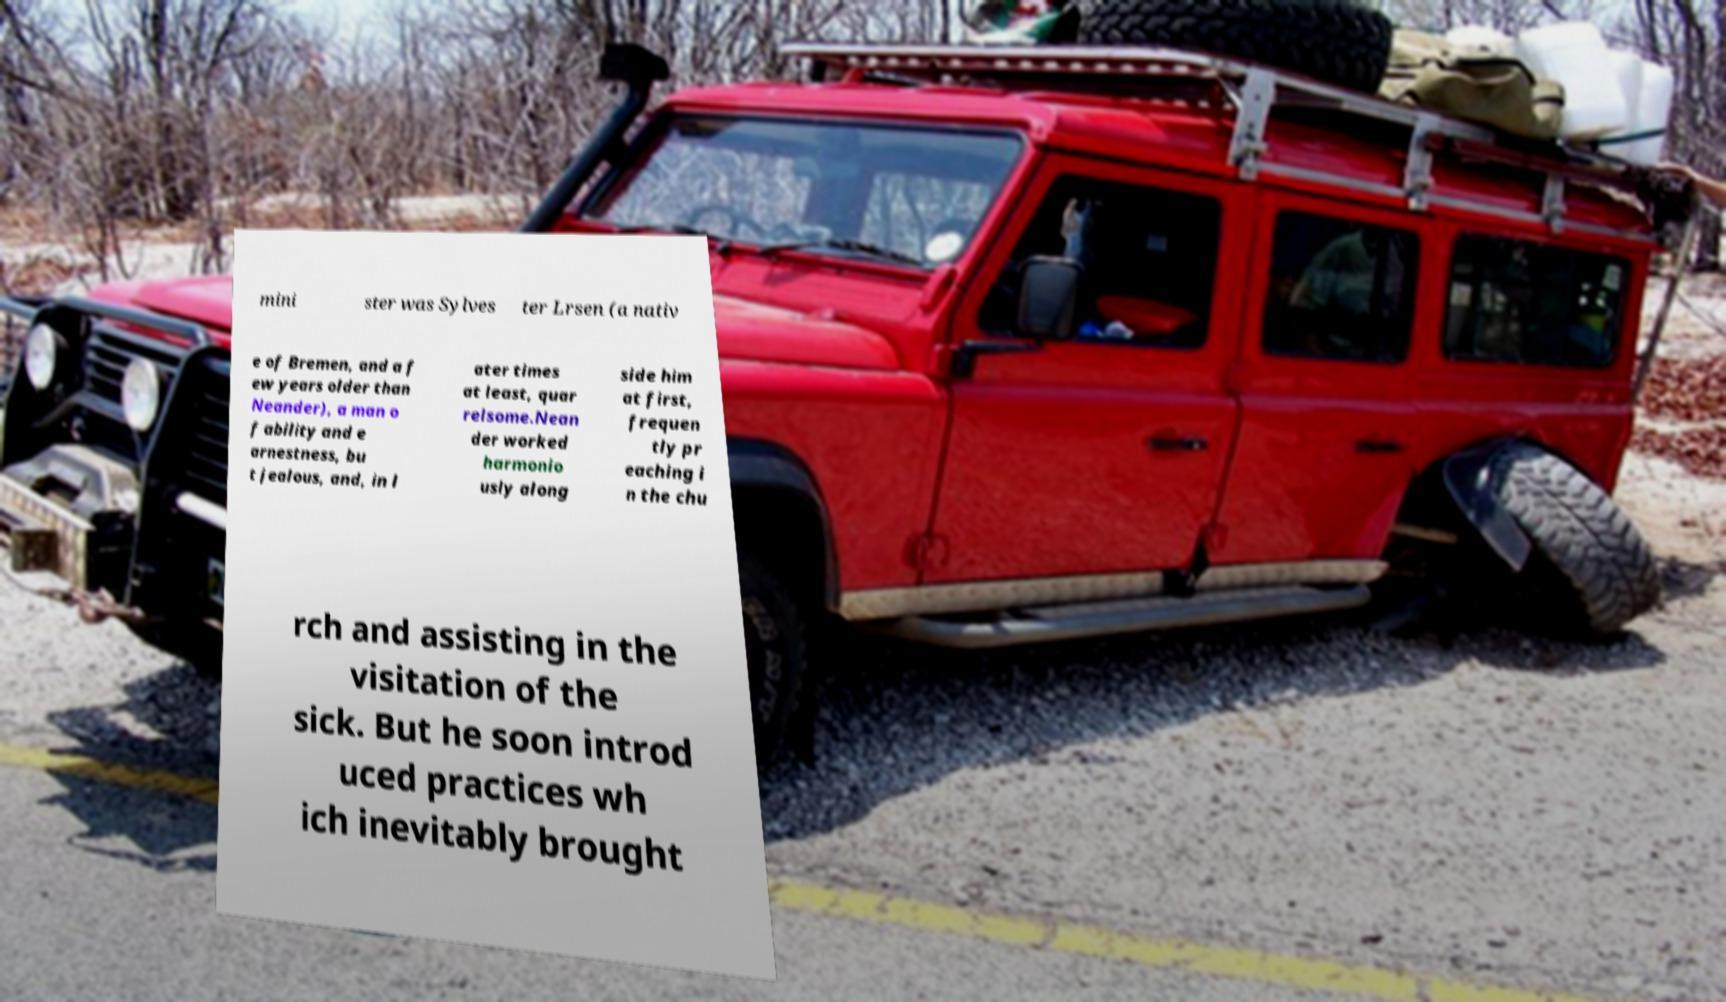For documentation purposes, I need the text within this image transcribed. Could you provide that? mini ster was Sylves ter Lrsen (a nativ e of Bremen, and a f ew years older than Neander), a man o f ability and e arnestness, bu t jealous, and, in l ater times at least, quar relsome.Nean der worked harmonio usly along side him at first, frequen tly pr eaching i n the chu rch and assisting in the visitation of the sick. But he soon introd uced practices wh ich inevitably brought 